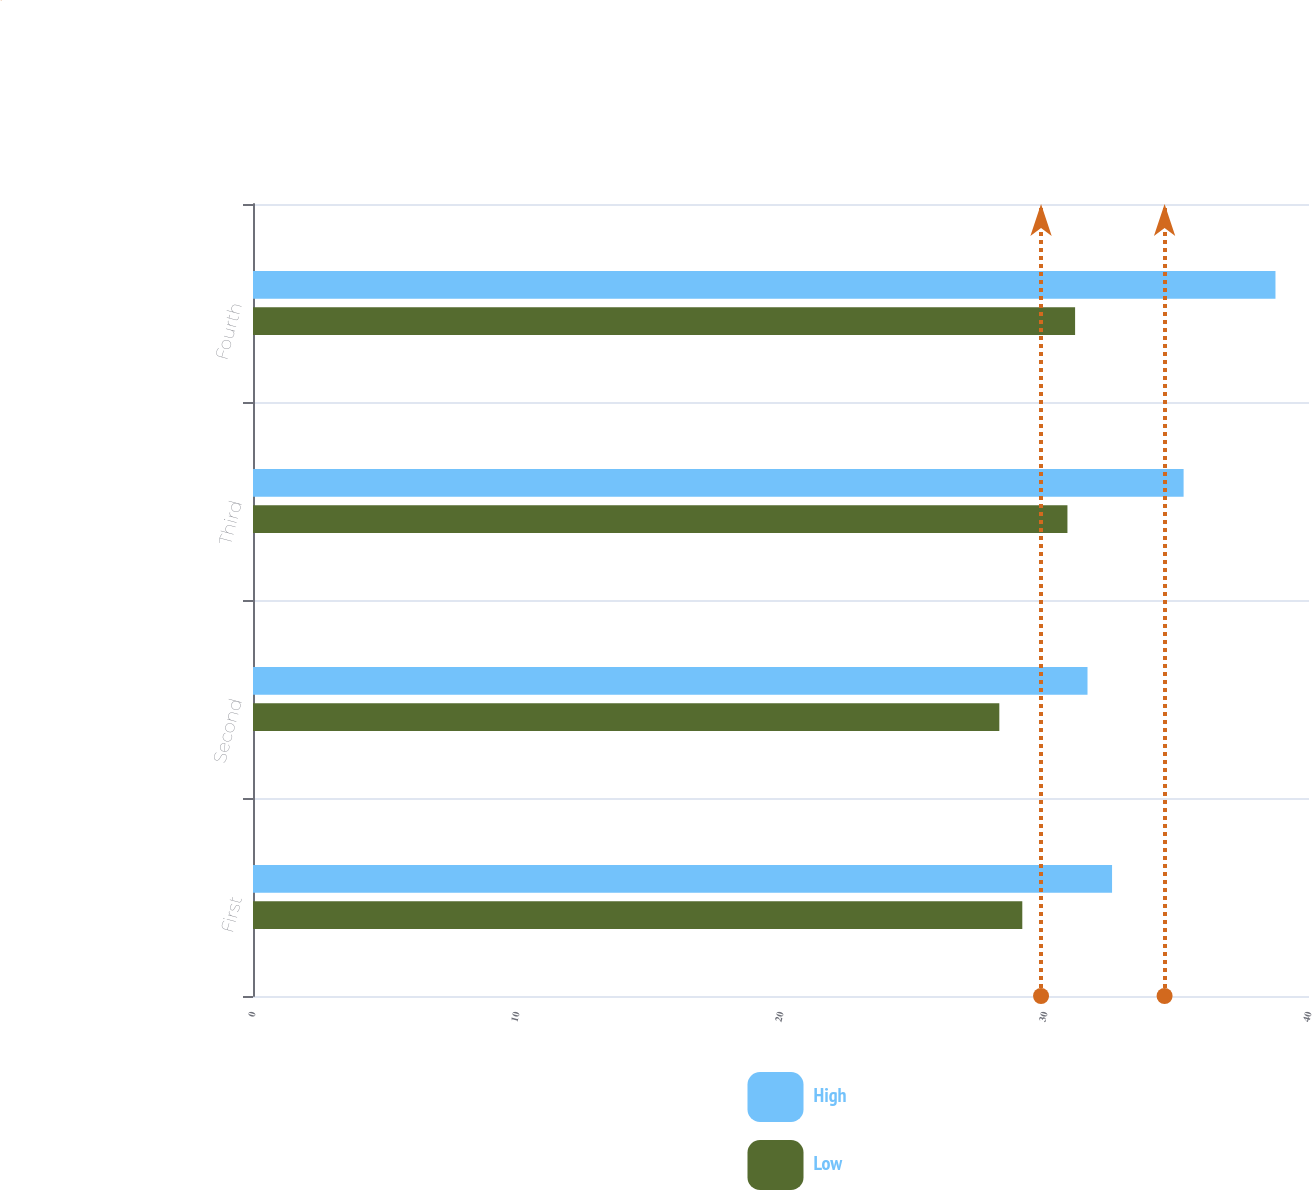<chart> <loc_0><loc_0><loc_500><loc_500><stacked_bar_chart><ecel><fcel>First<fcel>Second<fcel>Third<fcel>Fourth<nl><fcel>High<fcel>32.54<fcel>31.61<fcel>35.25<fcel>38.73<nl><fcel>Low<fcel>29.14<fcel>28.27<fcel>30.85<fcel>31.14<nl></chart> 